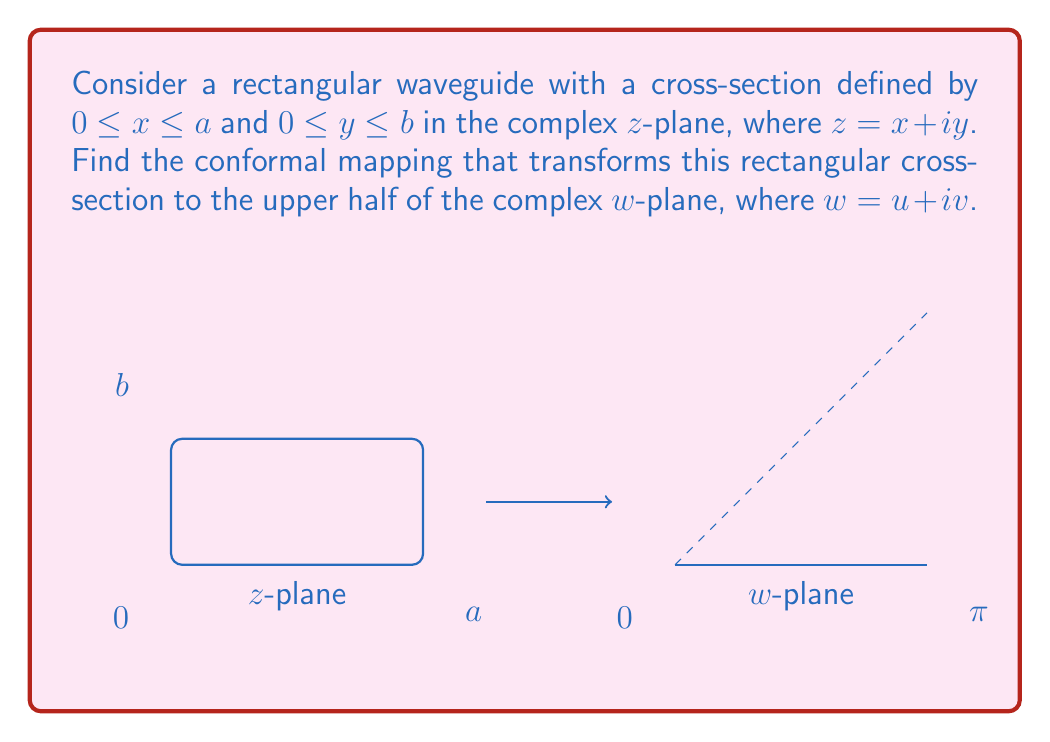Give your solution to this math problem. To find the conformal mapping that transforms the rectangular waveguide cross-section to the upper half-plane, we'll follow these steps:

1) First, we'll use the Schwarz-Christoffel transformation to map the upper half-plane to a rectangle. Then, we'll invert this mapping to get our desired transformation.

2) The Schwarz-Christoffel transformation for mapping the upper half-plane to a rectangle is:

   $$w = K \int_0^z \frac{d\zeta}{\sqrt{(1-\zeta^2)(1-k^2\zeta^2)}}$$

   where $K$ is a scaling factor and $k$ is the modulus of the elliptic integral.

3) The inverse of this transformation is the Jacobi elliptic function $\text{sn}$:

   $$z = \text{sn}(w, k)$$

4) To map our rectangle in the $z$-plane to the upper half of the $w$-plane, we need to use this inverse transformation with appropriate scaling:

   $$w = \frac{2K}{a} z$$

   where $K = K(k)$ is the complete elliptic integral of the first kind.

5) The modulus $k$ is related to the aspect ratio of the rectangle:

   $$k = \frac{a}{b}$$

6) The complete mapping is thus:

   $$w = \frac{2K(k)}{a} \cdot \text{sn}^{-1}\left(\frac{z}{a}, k\right)$$

7) This mapping transforms the rectangle $0 \leq x \leq a$, $0 \leq y \leq b$ in the $z$-plane to the strip $0 \leq u \leq \pi$, $v \geq 0$ in the $w$-plane.
Answer: $w = \frac{2K(k)}{a} \cdot \text{sn}^{-1}\left(\frac{z}{a}, k\right)$, where $k = \frac{a}{b}$ 